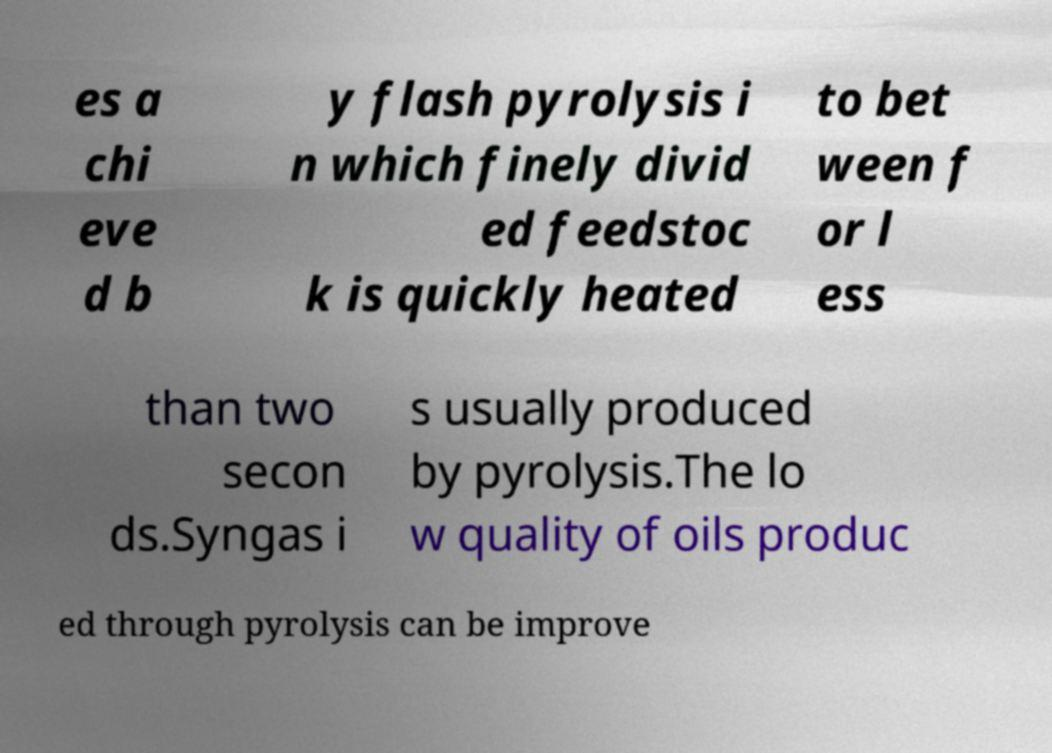Can you accurately transcribe the text from the provided image for me? es a chi eve d b y flash pyrolysis i n which finely divid ed feedstoc k is quickly heated to bet ween f or l ess than two secon ds.Syngas i s usually produced by pyrolysis.The lo w quality of oils produc ed through pyrolysis can be improve 